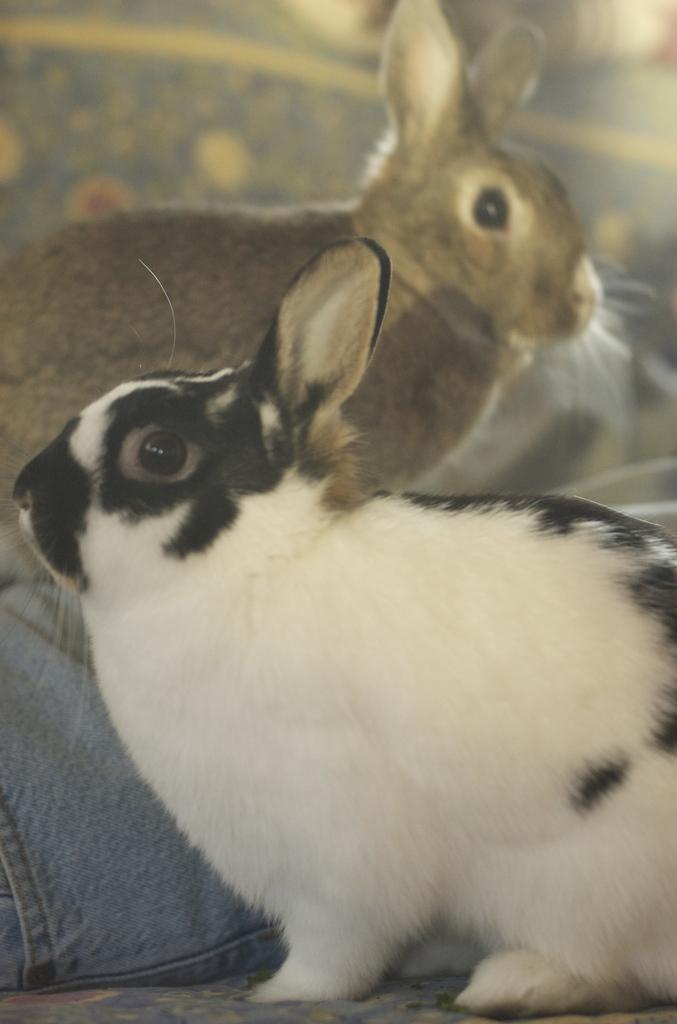How many rabbits are present in the image? There are two rabbits in the image. Can you describe the color of each rabbit? One rabbit is black and white in color, while the other rabbit is brown in color. What is the distance between the rabbits and the door in the image? There is no door present in the image, so it is not possible to determine the distance between the rabbits and a door. 